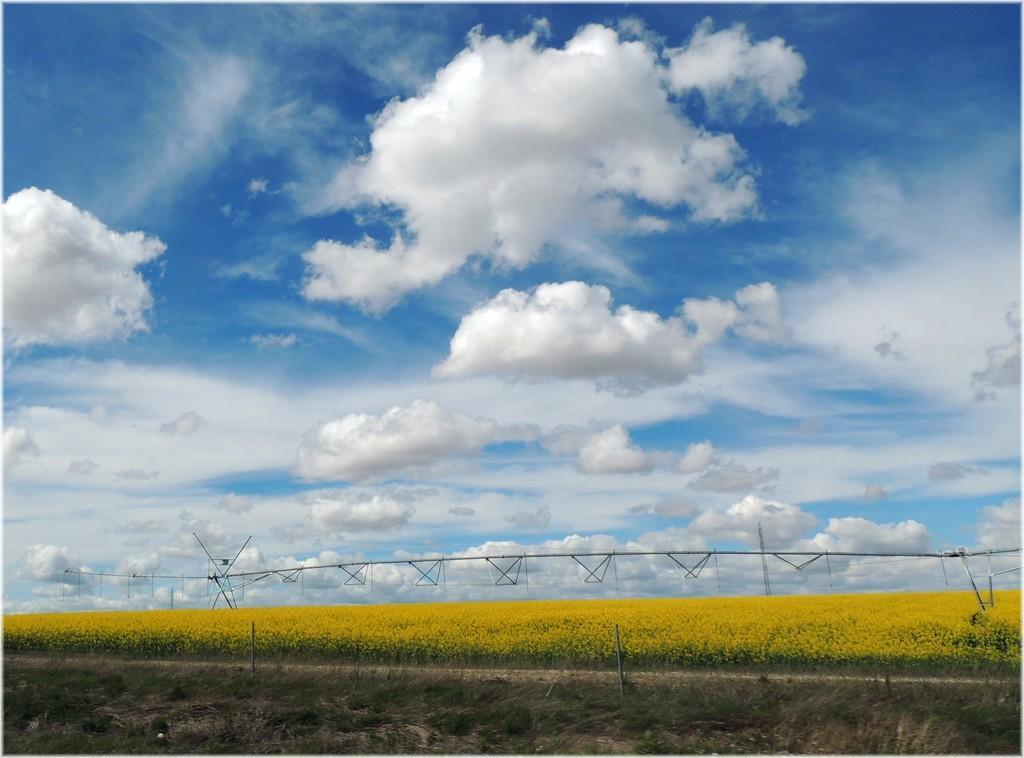Please provide a concise description of this image. In this image there are so many flower plants in the middle. At the bottom there is grass. At the top there is the sky. In the middle there are poles to which there are wires. 